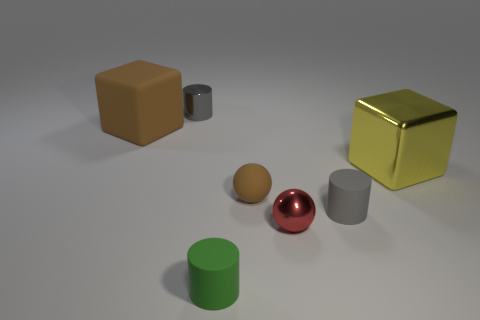Do the big rubber thing and the metallic sphere have the same color?
Ensure brevity in your answer.  No. How many small cylinders are in front of the metallic cylinder and behind the tiny green object?
Ensure brevity in your answer.  1. How many matte things are big things or balls?
Give a very brief answer. 2. There is a cube right of the gray cylinder on the left side of the small red sphere; what is it made of?
Ensure brevity in your answer.  Metal. The big thing that is the same color as the rubber ball is what shape?
Provide a short and direct response. Cube. There is a object that is the same size as the brown matte block; what shape is it?
Make the answer very short. Cube. Are there fewer brown blocks than objects?
Give a very brief answer. Yes. Are there any tiny gray metallic objects right of the gray cylinder that is behind the big rubber object?
Your response must be concise. No. What shape is the tiny brown thing that is the same material as the brown cube?
Your response must be concise. Sphere. Are there any other things that are the same color as the shiny sphere?
Offer a very short reply. No. 